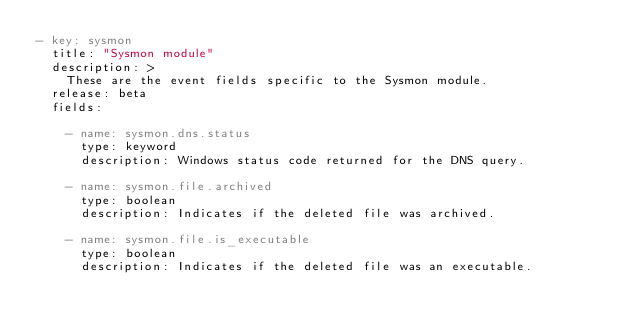Convert code to text. <code><loc_0><loc_0><loc_500><loc_500><_YAML_>- key: sysmon
  title: "Sysmon module"
  description: >
    These are the event fields specific to the Sysmon module.
  release: beta
  fields:

    - name: sysmon.dns.status
      type: keyword
      description: Windows status code returned for the DNS query.

    - name: sysmon.file.archived
      type: boolean
      description: Indicates if the deleted file was archived.

    - name: sysmon.file.is_executable
      type: boolean
      description: Indicates if the deleted file was an executable.
</code> 